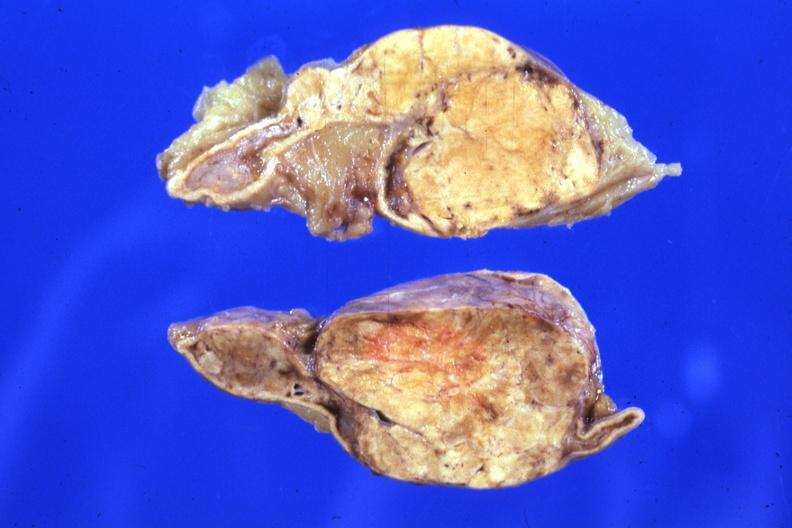what does this image show?
Answer the question using a single word or phrase. Fixed tissue sectioned gland rather large lesion 